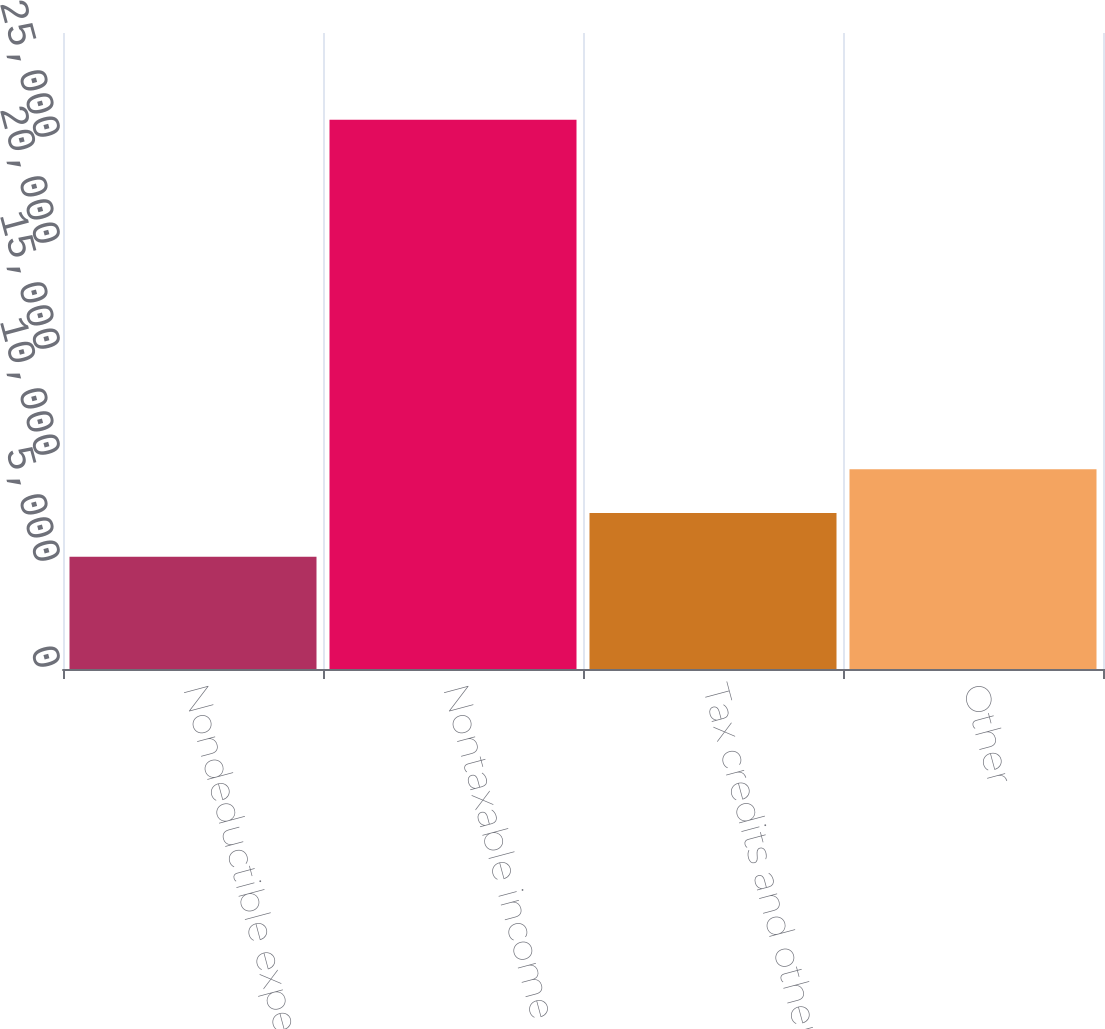Convert chart to OTSL. <chart><loc_0><loc_0><loc_500><loc_500><bar_chart><fcel>Nondeductible expenses<fcel>Nontaxable income<fcel>Tax credits and other taxes<fcel>Other<nl><fcel>5299<fcel>25905<fcel>7359.6<fcel>9420.2<nl></chart> 